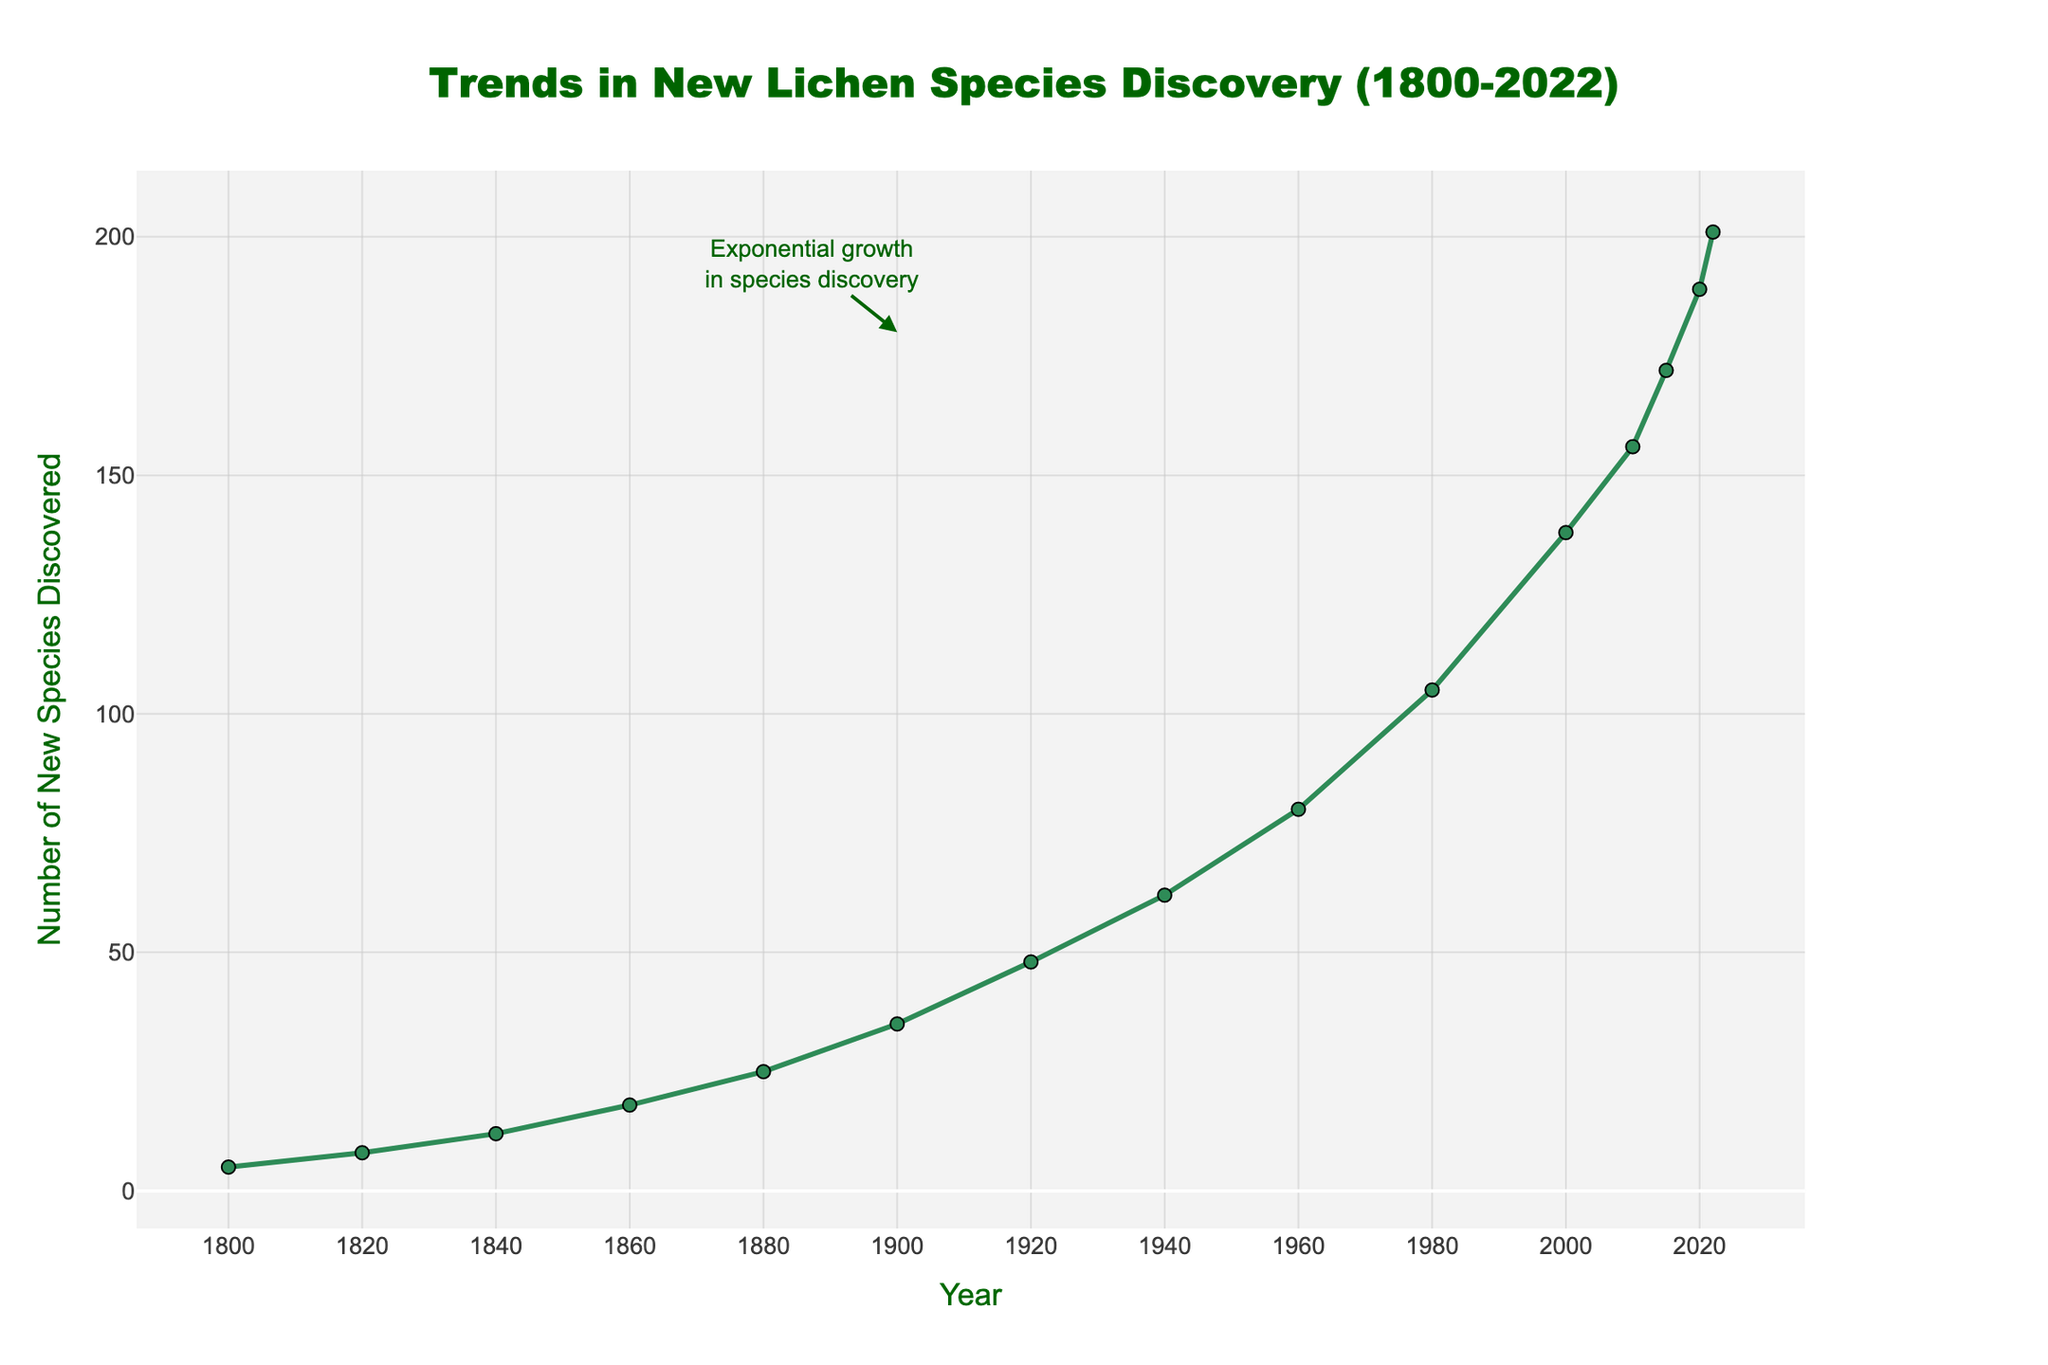What is the overall trend in the discovery of new lichen species from 1800 to 2022? The graph shows an overall increasing trend, with a noticeable exponential growth in the number of new species discovered, especially from the 1900s onwards.
Answer: Increasing trend During which period did the discovery of new lichen species start to significantly rise? Observing the graph, the period around the early 1900s marks the beginning of a significant rise in the discovery of new lichen species, indicated by a steeper slope on the plot.
Answer: Early 1900s How many more new lichen species were discovered in 2022 compared to 1900? In 1900, there were 35 new species discovered and in 2022, 201 new species. The difference is calculated as 201 - 35 = 166.
Answer: 166 What is the average number of new lichen species discovered per year between 2000 and 2022? The number of new species discovered in 2000 is 138 and 201 in 2022. There are 23 years between 2000 and 2022, inclusive. The average per year is (201 - 138) / 23 = 63 / 23 ≈ 2.74.
Answer: 2.74 During which decade did the discovery of new lichen species exceed 100 for the first time? The graph shows that the number of new species discovered exceeded 100 in 1980.
Answer: 1980s Which year saw the highest number of new lichen species discoveries? According to the graph, 2022 recorded the highest number of new lichen species discoveries, with 201 discoveries.
Answer: 2022 Compare the rate of discovery between the periods 1800-1900 and 1900-2000. Which period shows a higher rate? From 1800 to 1900, the discoveries increased from 5 to 35 (30 discoveries in 100 years). From 1900 to 2000, discoveries increased from 35 to 138 (103 discoveries in 100 years). The rate of discovery is higher in the 1900-2000 period.
Answer: 1900-2000 How does the number of new species discovered in 2010 compare to that in 2000? In 2000, there were 138 new species discovered, and in 2010, there were 156. The increase is 156 - 138 = 18.
Answer: Increase by 18 What is the increase in the number of new lichen species discoveries from 1980 to 2020? In 1980, 105 new species were discovered, and in 2020, the number was 189. The increase is 189 - 105 = 84.
Answer: 84 What can you infer about the future trend of lichen species discovery based on the graph? Based on the exponential growth trend shown in the graph, it can be inferred that the discovery of new lichen species may continue to increase at a rapid pace in the future.
Answer: Continued increase 